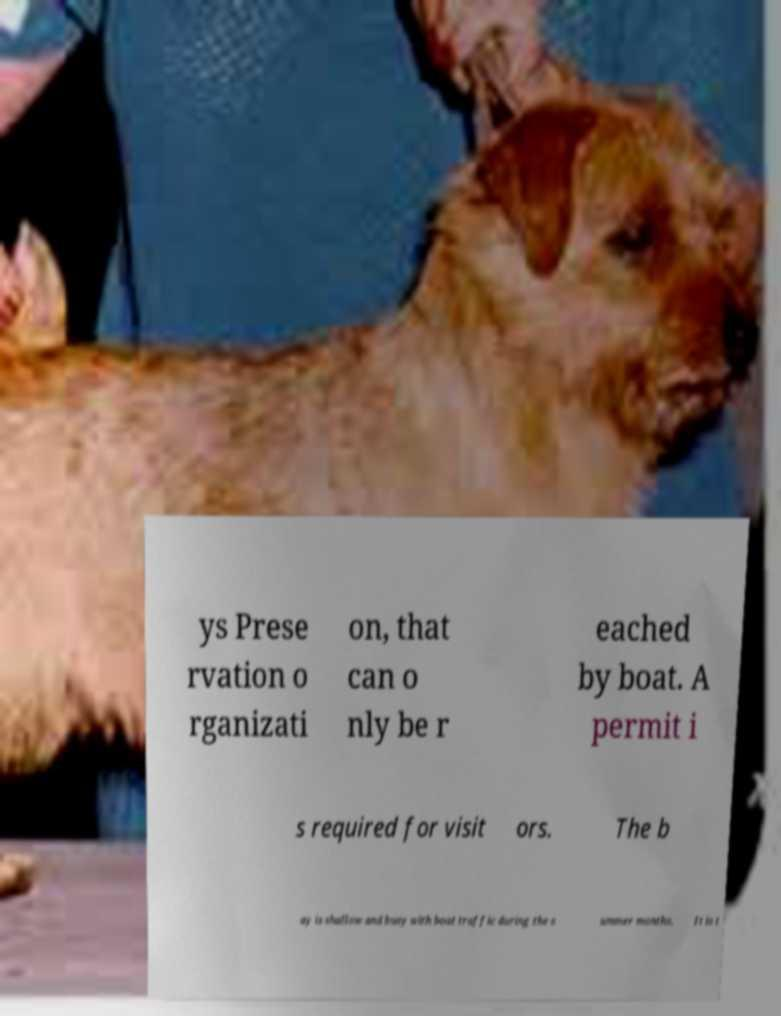There's text embedded in this image that I need extracted. Can you transcribe it verbatim? ys Prese rvation o rganizati on, that can o nly be r eached by boat. A permit i s required for visit ors. The b ay is shallow and busy with boat traffic during the s ummer months. It is t 